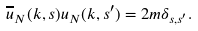<formula> <loc_0><loc_0><loc_500><loc_500>\overline { u } _ { N } ( k , s ) u _ { N } ( k , s ^ { \prime } ) = 2 m \delta _ { s , s ^ { \prime } } .</formula> 